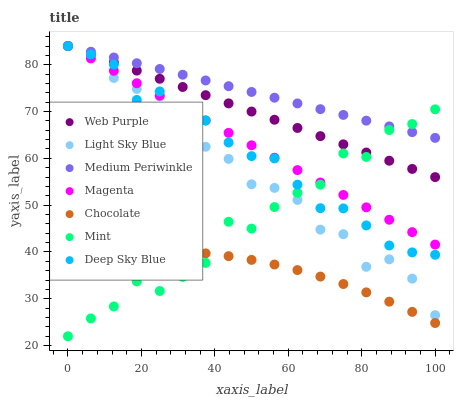Does Chocolate have the minimum area under the curve?
Answer yes or no. Yes. Does Medium Periwinkle have the maximum area under the curve?
Answer yes or no. Yes. Does Web Purple have the minimum area under the curve?
Answer yes or no. No. Does Web Purple have the maximum area under the curve?
Answer yes or no. No. Is Web Purple the smoothest?
Answer yes or no. Yes. Is Mint the roughest?
Answer yes or no. Yes. Is Chocolate the smoothest?
Answer yes or no. No. Is Chocolate the roughest?
Answer yes or no. No. Does Mint have the lowest value?
Answer yes or no. Yes. Does Chocolate have the lowest value?
Answer yes or no. No. Does Magenta have the highest value?
Answer yes or no. Yes. Does Chocolate have the highest value?
Answer yes or no. No. Is Chocolate less than Deep Sky Blue?
Answer yes or no. Yes. Is Web Purple greater than Chocolate?
Answer yes or no. Yes. Does Light Sky Blue intersect Deep Sky Blue?
Answer yes or no. Yes. Is Light Sky Blue less than Deep Sky Blue?
Answer yes or no. No. Is Light Sky Blue greater than Deep Sky Blue?
Answer yes or no. No. Does Chocolate intersect Deep Sky Blue?
Answer yes or no. No. 